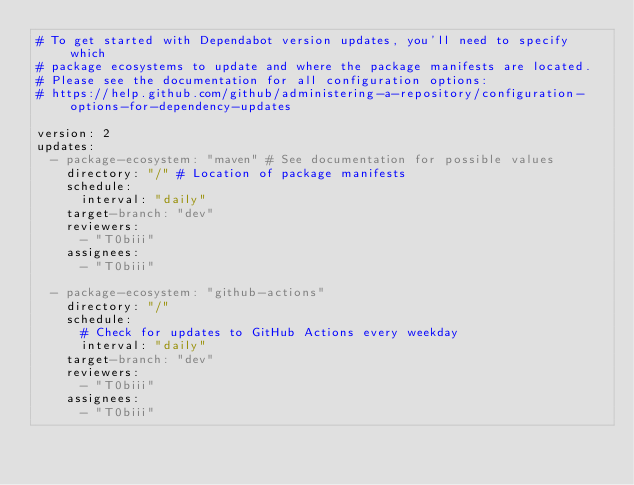<code> <loc_0><loc_0><loc_500><loc_500><_YAML_># To get started with Dependabot version updates, you'll need to specify which
# package ecosystems to update and where the package manifests are located.
# Please see the documentation for all configuration options:
# https://help.github.com/github/administering-a-repository/configuration-options-for-dependency-updates

version: 2
updates:
  - package-ecosystem: "maven" # See documentation for possible values
    directory: "/" # Location of package manifests
    schedule:
      interval: "daily"
    target-branch: "dev"
    reviewers:
      - "T0biii"
    assignees:
      - "T0biii"

  - package-ecosystem: "github-actions"
    directory: "/"
    schedule:
      # Check for updates to GitHub Actions every weekday
      interval: "daily"
    target-branch: "dev"
    reviewers:
      - "T0biii"
    assignees:
      - "T0biii"
</code> 